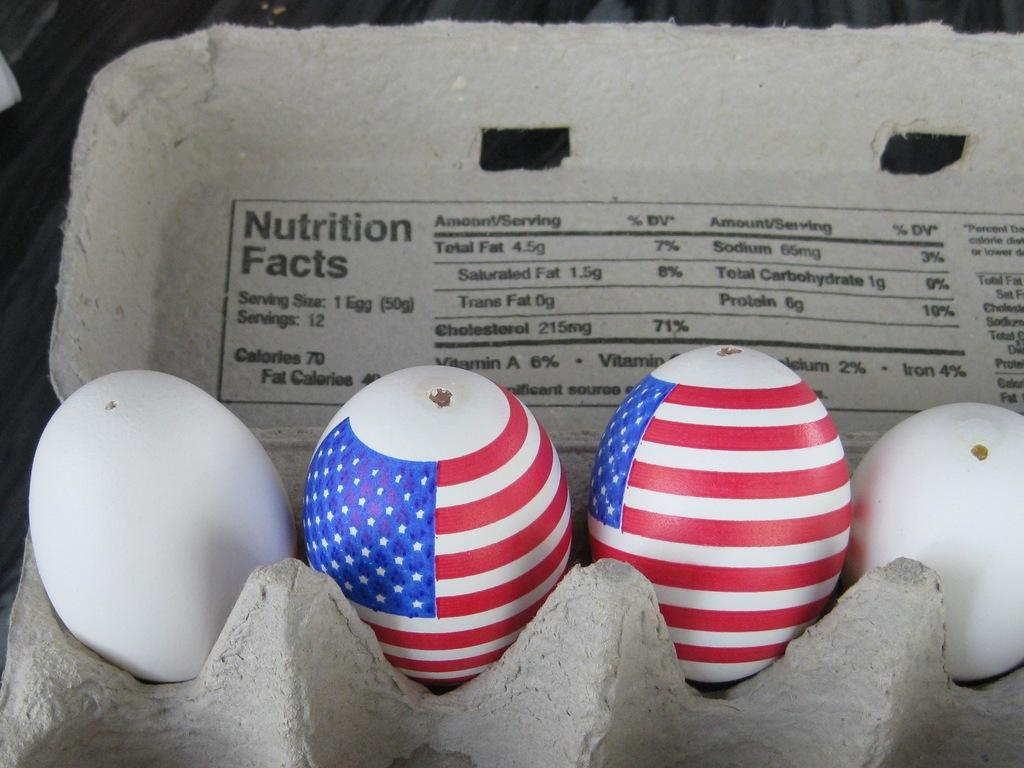How many eggs are visible in the image? There are four eggs in the image. Where are the eggs stored in the image? The eggs are kept in an egg container. Are there any eggs with unique features in the image? Yes, two of the eggs have paint on them. What scent can be detected from the eggs in the image? There is no mention of a scent associated with the eggs in the image. --- Facts: 1. There is a person in the image. 2. The person is wearing a hat. 3. The person is holding a book. 4. The background of the image is a park. Absurd Topics: dinosaur, ocean, parrot Conversation: Who or what is present in the image? There is a person in the image. What is the person wearing in the image? The person is wearing a hat in the image. What is the person holding in the image? The person is holding a book in the image. What can be seen in the background of the image? The background of the image is a park. Reasoning: Let's think step by step in order to produce the conversation. We start by identifying the main subject in the image, which is the person. Then, we describe the person's attire, specifically mentioning the hat. Next, we observe the action of the person, noting that they are holding a book. Finally, we describe the setting where the person is located, which is a park. Absurd Question/Answer: Can a dinosaur be seen in the image? No, there is no dinosaur present in the image. --- Facts: 1. There is a cat in the image. 2. The cat is sitting on a windowsill. 3. The windowsill is located near a tree. 4. The tree has green leaves. Absurd Topics: elephant, jungle, kangaroo Conversation: What type of animal is present in the image? There is a cat in the image. Where is the cat located in the image? The cat is sitting on a windowsill in the image. What can be seen in the background of the image? The windowsill is located near a tree in the image. What is the condition of the tree in the image? The tree has green leaves in the image. Reasoning: Let's think step by step in order to produce the conversation. We start by identifying the main subject in the image, which is the cat. Then, we describe the location of the cat, which is on a windowsill. Next, we observe the background of the image, noting that there is a tree near the windowsill. Finally, we describe the condition of the tree, which is that it has green leaves. Absurd Question/Answer: Can an elephant be seen playing with the cat in the image? No, there 